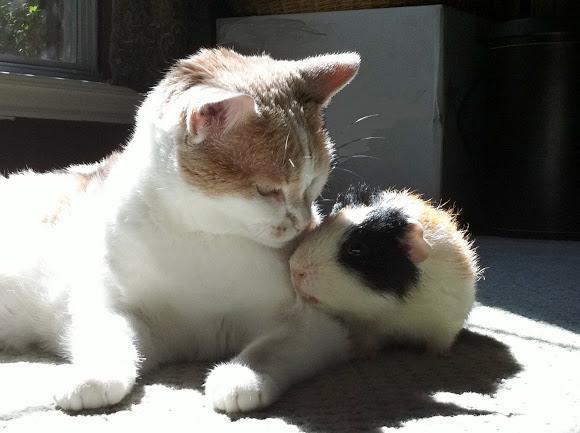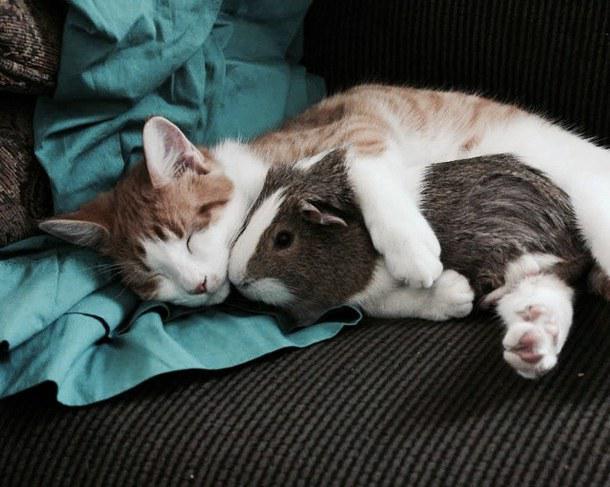The first image is the image on the left, the second image is the image on the right. Examine the images to the left and right. Is the description "There are three species of animals." accurate? Answer yes or no. No. 